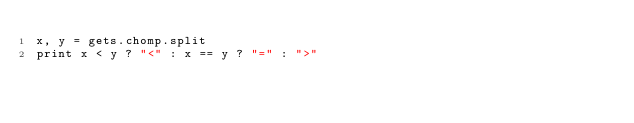Convert code to text. <code><loc_0><loc_0><loc_500><loc_500><_Ruby_>x, y = gets.chomp.split
print x < y ? "<" : x == y ? "=" : ">"</code> 